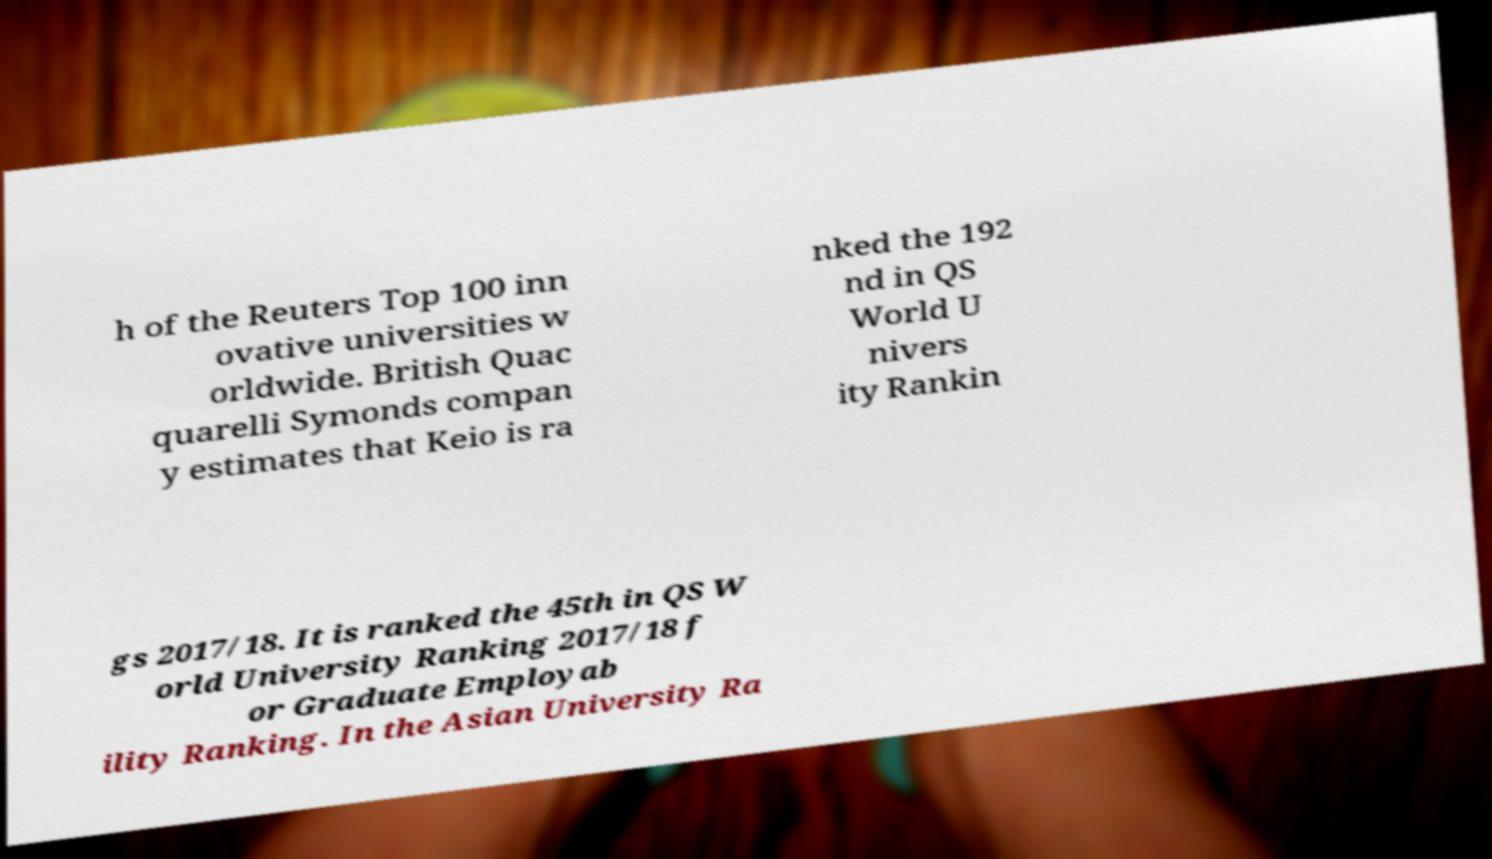For documentation purposes, I need the text within this image transcribed. Could you provide that? h of the Reuters Top 100 inn ovative universities w orldwide. British Quac quarelli Symonds compan y estimates that Keio is ra nked the 192 nd in QS World U nivers ity Rankin gs 2017/18. It is ranked the 45th in QS W orld University Ranking 2017/18 f or Graduate Employab ility Ranking. In the Asian University Ra 